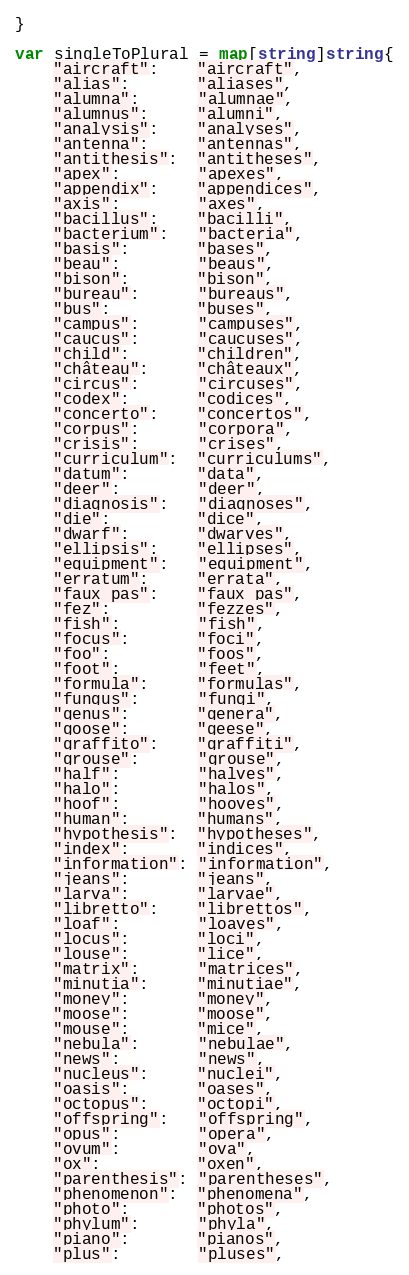<code> <loc_0><loc_0><loc_500><loc_500><_Go_>}

var singleToPlural = map[string]string{
	"aircraft":    "aircraft",
	"alias":       "aliases",
	"alumna":      "alumnae",
	"alumnus":     "alumni",
	"analysis":    "analyses",
	"antenna":     "antennas",
	"antithesis":  "antitheses",
	"apex":        "apexes",
	"appendix":    "appendices",
	"axis":        "axes",
	"bacillus":    "bacilli",
	"bacterium":   "bacteria",
	"basis":       "bases",
	"beau":        "beaus",
	"bison":       "bison",
	"bureau":      "bureaus",
	"bus":         "buses",
	"campus":      "campuses",
	"caucus":      "caucuses",
	"child":       "children",
	"château":     "châteaux",
	"circus":      "circuses",
	"codex":       "codices",
	"concerto":    "concertos",
	"corpus":      "corpora",
	"crisis":      "crises",
	"curriculum":  "curriculums",
	"datum":       "data",
	"deer":        "deer",
	"diagnosis":   "diagnoses",
	"die":         "dice",
	"dwarf":       "dwarves",
	"ellipsis":    "ellipses",
	"equipment":   "equipment",
	"erratum":     "errata",
	"faux pas":    "faux pas",
	"fez":         "fezzes",
	"fish":        "fish",
	"focus":       "foci",
	"foo":         "foos",
	"foot":        "feet",
	"formula":     "formulas",
	"fungus":      "fungi",
	"genus":       "genera",
	"goose":       "geese",
	"graffito":    "graffiti",
	"grouse":      "grouse",
	"half":        "halves",
	"halo":        "halos",
	"hoof":        "hooves",
	"human":       "humans",
	"hypothesis":  "hypotheses",
	"index":       "indices",
	"information": "information",
	"jeans":       "jeans",
	"larva":       "larvae",
	"libretto":    "librettos",
	"loaf":        "loaves",
	"locus":       "loci",
	"louse":       "lice",
	"matrix":      "matrices",
	"minutia":     "minutiae",
	"money":       "money",
	"moose":       "moose",
	"mouse":       "mice",
	"nebula":      "nebulae",
	"news":        "news",
	"nucleus":     "nuclei",
	"oasis":       "oases",
	"octopus":     "octopi",
	"offspring":   "offspring",
	"opus":        "opera",
	"ovum":        "ova",
	"ox":          "oxen",
	"parenthesis": "parentheses",
	"phenomenon":  "phenomena",
	"photo":       "photos",
	"phylum":      "phyla",
	"piano":       "pianos",
	"plus":        "pluses",</code> 